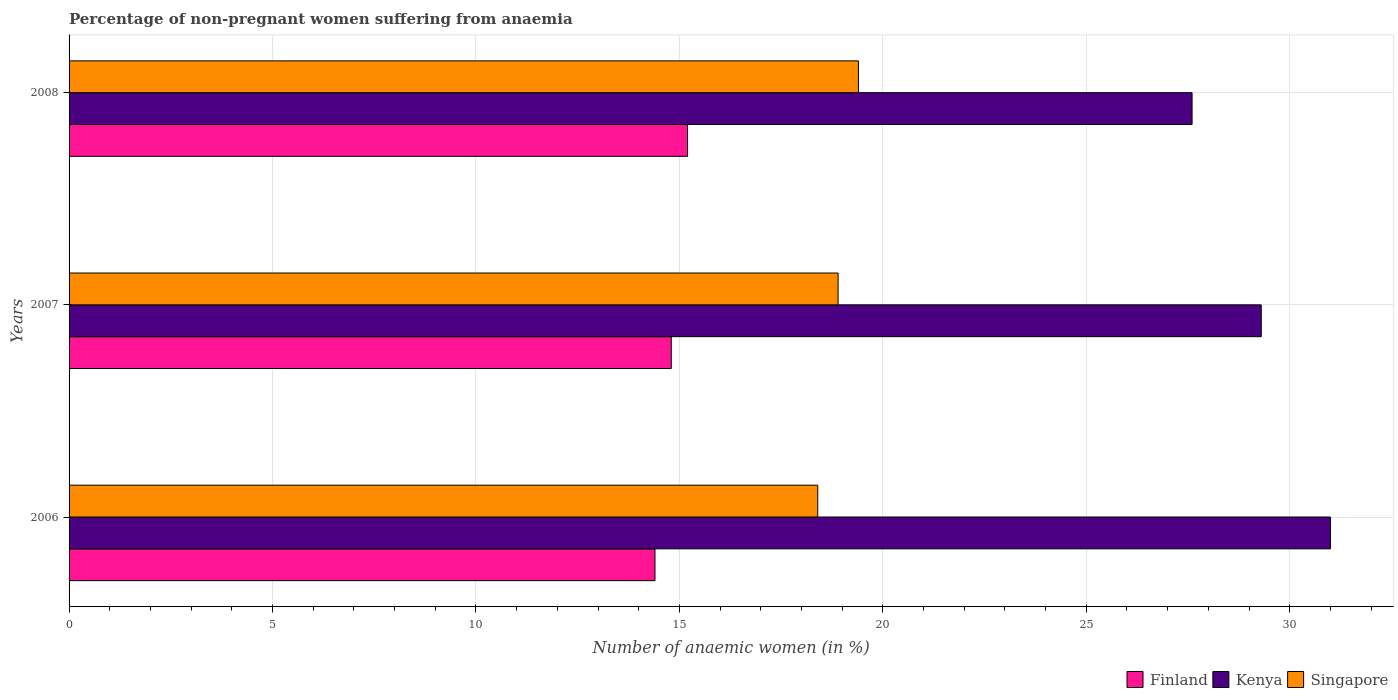How many different coloured bars are there?
Your answer should be very brief. 3. How many groups of bars are there?
Keep it short and to the point. 3. Are the number of bars on each tick of the Y-axis equal?
Make the answer very short. Yes. What is the label of the 3rd group of bars from the top?
Make the answer very short. 2006. In how many cases, is the number of bars for a given year not equal to the number of legend labels?
Provide a succinct answer. 0. What is the percentage of non-pregnant women suffering from anaemia in Kenya in 2008?
Your answer should be very brief. 27.6. In which year was the percentage of non-pregnant women suffering from anaemia in Singapore minimum?
Provide a short and direct response. 2006. What is the total percentage of non-pregnant women suffering from anaemia in Finland in the graph?
Make the answer very short. 44.4. What is the difference between the percentage of non-pregnant women suffering from anaemia in Finland in 2006 and that in 2008?
Your answer should be very brief. -0.8. What is the difference between the percentage of non-pregnant women suffering from anaemia in Singapore in 2006 and the percentage of non-pregnant women suffering from anaemia in Finland in 2007?
Provide a succinct answer. 3.6. In the year 2008, what is the difference between the percentage of non-pregnant women suffering from anaemia in Finland and percentage of non-pregnant women suffering from anaemia in Kenya?
Your answer should be very brief. -12.4. In how many years, is the percentage of non-pregnant women suffering from anaemia in Kenya greater than 1 %?
Offer a very short reply. 3. What is the ratio of the percentage of non-pregnant women suffering from anaemia in Finland in 2007 to that in 2008?
Make the answer very short. 0.97. What is the difference between the highest and the second highest percentage of non-pregnant women suffering from anaemia in Singapore?
Offer a very short reply. 0.5. What is the difference between the highest and the lowest percentage of non-pregnant women suffering from anaemia in Kenya?
Your answer should be compact. 3.4. What does the 3rd bar from the top in 2008 represents?
Keep it short and to the point. Finland. What does the 3rd bar from the bottom in 2008 represents?
Your answer should be compact. Singapore. How many bars are there?
Your answer should be compact. 9. Are the values on the major ticks of X-axis written in scientific E-notation?
Your answer should be compact. No. Where does the legend appear in the graph?
Give a very brief answer. Bottom right. How are the legend labels stacked?
Your answer should be very brief. Horizontal. What is the title of the graph?
Your answer should be very brief. Percentage of non-pregnant women suffering from anaemia. Does "Hong Kong" appear as one of the legend labels in the graph?
Give a very brief answer. No. What is the label or title of the X-axis?
Your response must be concise. Number of anaemic women (in %). What is the Number of anaemic women (in %) of Finland in 2006?
Provide a short and direct response. 14.4. What is the Number of anaemic women (in %) of Singapore in 2006?
Your answer should be very brief. 18.4. What is the Number of anaemic women (in %) in Kenya in 2007?
Offer a very short reply. 29.3. What is the Number of anaemic women (in %) of Singapore in 2007?
Make the answer very short. 18.9. What is the Number of anaemic women (in %) in Kenya in 2008?
Offer a very short reply. 27.6. Across all years, what is the maximum Number of anaemic women (in %) of Finland?
Your response must be concise. 15.2. Across all years, what is the maximum Number of anaemic women (in %) in Kenya?
Provide a succinct answer. 31. Across all years, what is the maximum Number of anaemic women (in %) in Singapore?
Provide a succinct answer. 19.4. Across all years, what is the minimum Number of anaemic women (in %) of Kenya?
Give a very brief answer. 27.6. Across all years, what is the minimum Number of anaemic women (in %) in Singapore?
Your answer should be very brief. 18.4. What is the total Number of anaemic women (in %) in Finland in the graph?
Give a very brief answer. 44.4. What is the total Number of anaemic women (in %) of Kenya in the graph?
Provide a succinct answer. 87.9. What is the total Number of anaemic women (in %) in Singapore in the graph?
Offer a terse response. 56.7. What is the difference between the Number of anaemic women (in %) of Kenya in 2006 and that in 2007?
Offer a very short reply. 1.7. What is the difference between the Number of anaemic women (in %) in Singapore in 2006 and that in 2007?
Offer a very short reply. -0.5. What is the difference between the Number of anaemic women (in %) of Kenya in 2006 and that in 2008?
Offer a very short reply. 3.4. What is the difference between the Number of anaemic women (in %) in Singapore in 2006 and that in 2008?
Provide a succinct answer. -1. What is the difference between the Number of anaemic women (in %) in Finland in 2007 and that in 2008?
Provide a succinct answer. -0.4. What is the difference between the Number of anaemic women (in %) of Kenya in 2007 and that in 2008?
Your answer should be compact. 1.7. What is the difference between the Number of anaemic women (in %) in Finland in 2006 and the Number of anaemic women (in %) in Kenya in 2007?
Give a very brief answer. -14.9. What is the difference between the Number of anaemic women (in %) in Finland in 2006 and the Number of anaemic women (in %) in Singapore in 2008?
Your answer should be very brief. -5. What is the difference between the Number of anaemic women (in %) in Kenya in 2006 and the Number of anaemic women (in %) in Singapore in 2008?
Give a very brief answer. 11.6. What is the difference between the Number of anaemic women (in %) of Kenya in 2007 and the Number of anaemic women (in %) of Singapore in 2008?
Make the answer very short. 9.9. What is the average Number of anaemic women (in %) in Kenya per year?
Your response must be concise. 29.3. What is the average Number of anaemic women (in %) of Singapore per year?
Provide a short and direct response. 18.9. In the year 2006, what is the difference between the Number of anaemic women (in %) of Finland and Number of anaemic women (in %) of Kenya?
Offer a terse response. -16.6. In the year 2006, what is the difference between the Number of anaemic women (in %) of Finland and Number of anaemic women (in %) of Singapore?
Ensure brevity in your answer.  -4. In the year 2006, what is the difference between the Number of anaemic women (in %) in Kenya and Number of anaemic women (in %) in Singapore?
Offer a very short reply. 12.6. In the year 2007, what is the difference between the Number of anaemic women (in %) of Finland and Number of anaemic women (in %) of Singapore?
Give a very brief answer. -4.1. In the year 2008, what is the difference between the Number of anaemic women (in %) in Finland and Number of anaemic women (in %) in Singapore?
Your answer should be very brief. -4.2. What is the ratio of the Number of anaemic women (in %) of Finland in 2006 to that in 2007?
Provide a succinct answer. 0.97. What is the ratio of the Number of anaemic women (in %) in Kenya in 2006 to that in 2007?
Your answer should be very brief. 1.06. What is the ratio of the Number of anaemic women (in %) of Singapore in 2006 to that in 2007?
Provide a short and direct response. 0.97. What is the ratio of the Number of anaemic women (in %) of Finland in 2006 to that in 2008?
Your answer should be compact. 0.95. What is the ratio of the Number of anaemic women (in %) in Kenya in 2006 to that in 2008?
Your response must be concise. 1.12. What is the ratio of the Number of anaemic women (in %) of Singapore in 2006 to that in 2008?
Make the answer very short. 0.95. What is the ratio of the Number of anaemic women (in %) in Finland in 2007 to that in 2008?
Your response must be concise. 0.97. What is the ratio of the Number of anaemic women (in %) in Kenya in 2007 to that in 2008?
Provide a short and direct response. 1.06. What is the ratio of the Number of anaemic women (in %) in Singapore in 2007 to that in 2008?
Give a very brief answer. 0.97. What is the difference between the highest and the second highest Number of anaemic women (in %) of Finland?
Give a very brief answer. 0.4. What is the difference between the highest and the second highest Number of anaemic women (in %) of Singapore?
Ensure brevity in your answer.  0.5. What is the difference between the highest and the lowest Number of anaemic women (in %) in Kenya?
Keep it short and to the point. 3.4. 